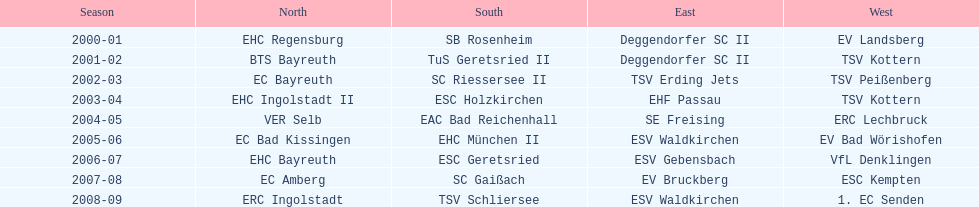What was the first club for the north in the 2000's? EHC Regensburg. 